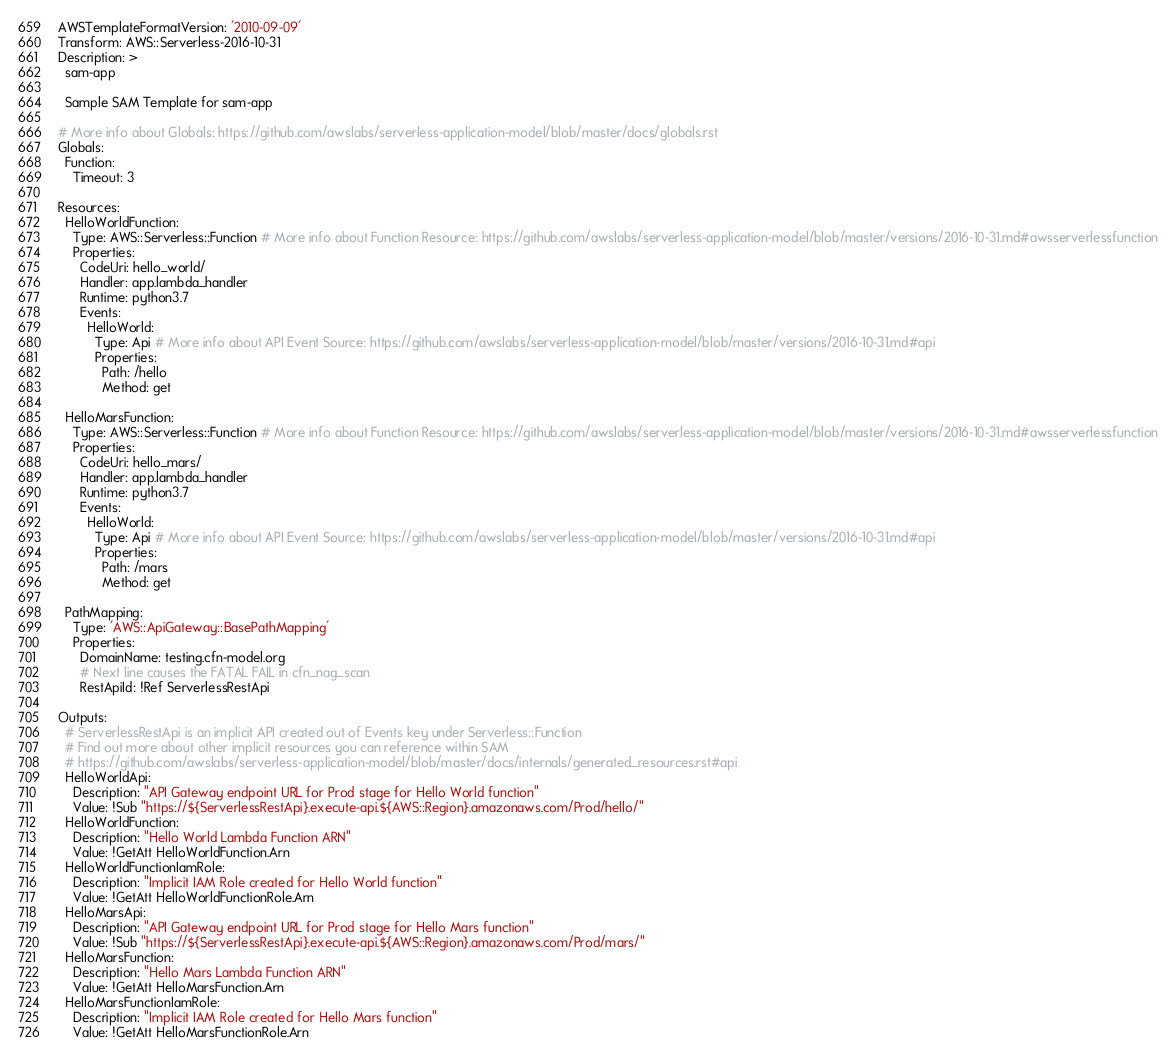Convert code to text. <code><loc_0><loc_0><loc_500><loc_500><_YAML_>AWSTemplateFormatVersion: '2010-09-09'
Transform: AWS::Serverless-2016-10-31
Description: >
  sam-app

  Sample SAM Template for sam-app

# More info about Globals: https://github.com/awslabs/serverless-application-model/blob/master/docs/globals.rst
Globals:
  Function:
    Timeout: 3

Resources:
  HelloWorldFunction:
    Type: AWS::Serverless::Function # More info about Function Resource: https://github.com/awslabs/serverless-application-model/blob/master/versions/2016-10-31.md#awsserverlessfunction
    Properties:
      CodeUri: hello_world/
      Handler: app.lambda_handler
      Runtime: python3.7
      Events:
        HelloWorld:
          Type: Api # More info about API Event Source: https://github.com/awslabs/serverless-application-model/blob/master/versions/2016-10-31.md#api
          Properties:
            Path: /hello
            Method: get

  HelloMarsFunction:
    Type: AWS::Serverless::Function # More info about Function Resource: https://github.com/awslabs/serverless-application-model/blob/master/versions/2016-10-31.md#awsserverlessfunction
    Properties:
      CodeUri: hello_mars/
      Handler: app.lambda_handler
      Runtime: python3.7
      Events:
        HelloWorld:
          Type: Api # More info about API Event Source: https://github.com/awslabs/serverless-application-model/blob/master/versions/2016-10-31.md#api
          Properties:
            Path: /mars
            Method: get

  PathMapping:
    Type: 'AWS::ApiGateway::BasePathMapping'
    Properties:
      DomainName: testing.cfn-model.org
      # Next line causes the FATAL FAIL in cfn_nag_scan
      RestApiId: !Ref ServerlessRestApi

Outputs:
  # ServerlessRestApi is an implicit API created out of Events key under Serverless::Function
  # Find out more about other implicit resources you can reference within SAM
  # https://github.com/awslabs/serverless-application-model/blob/master/docs/internals/generated_resources.rst#api
  HelloWorldApi:
    Description: "API Gateway endpoint URL for Prod stage for Hello World function"
    Value: !Sub "https://${ServerlessRestApi}.execute-api.${AWS::Region}.amazonaws.com/Prod/hello/"
  HelloWorldFunction:
    Description: "Hello World Lambda Function ARN"
    Value: !GetAtt HelloWorldFunction.Arn
  HelloWorldFunctionIamRole:
    Description: "Implicit IAM Role created for Hello World function"
    Value: !GetAtt HelloWorldFunctionRole.Arn
  HelloMarsApi:
    Description: "API Gateway endpoint URL for Prod stage for Hello Mars function"
    Value: !Sub "https://${ServerlessRestApi}.execute-api.${AWS::Region}.amazonaws.com/Prod/mars/"
  HelloMarsFunction:
    Description: "Hello Mars Lambda Function ARN"
    Value: !GetAtt HelloMarsFunction.Arn
  HelloMarsFunctionIamRole:
    Description: "Implicit IAM Role created for Hello Mars function"
    Value: !GetAtt HelloMarsFunctionRole.Arn
</code> 